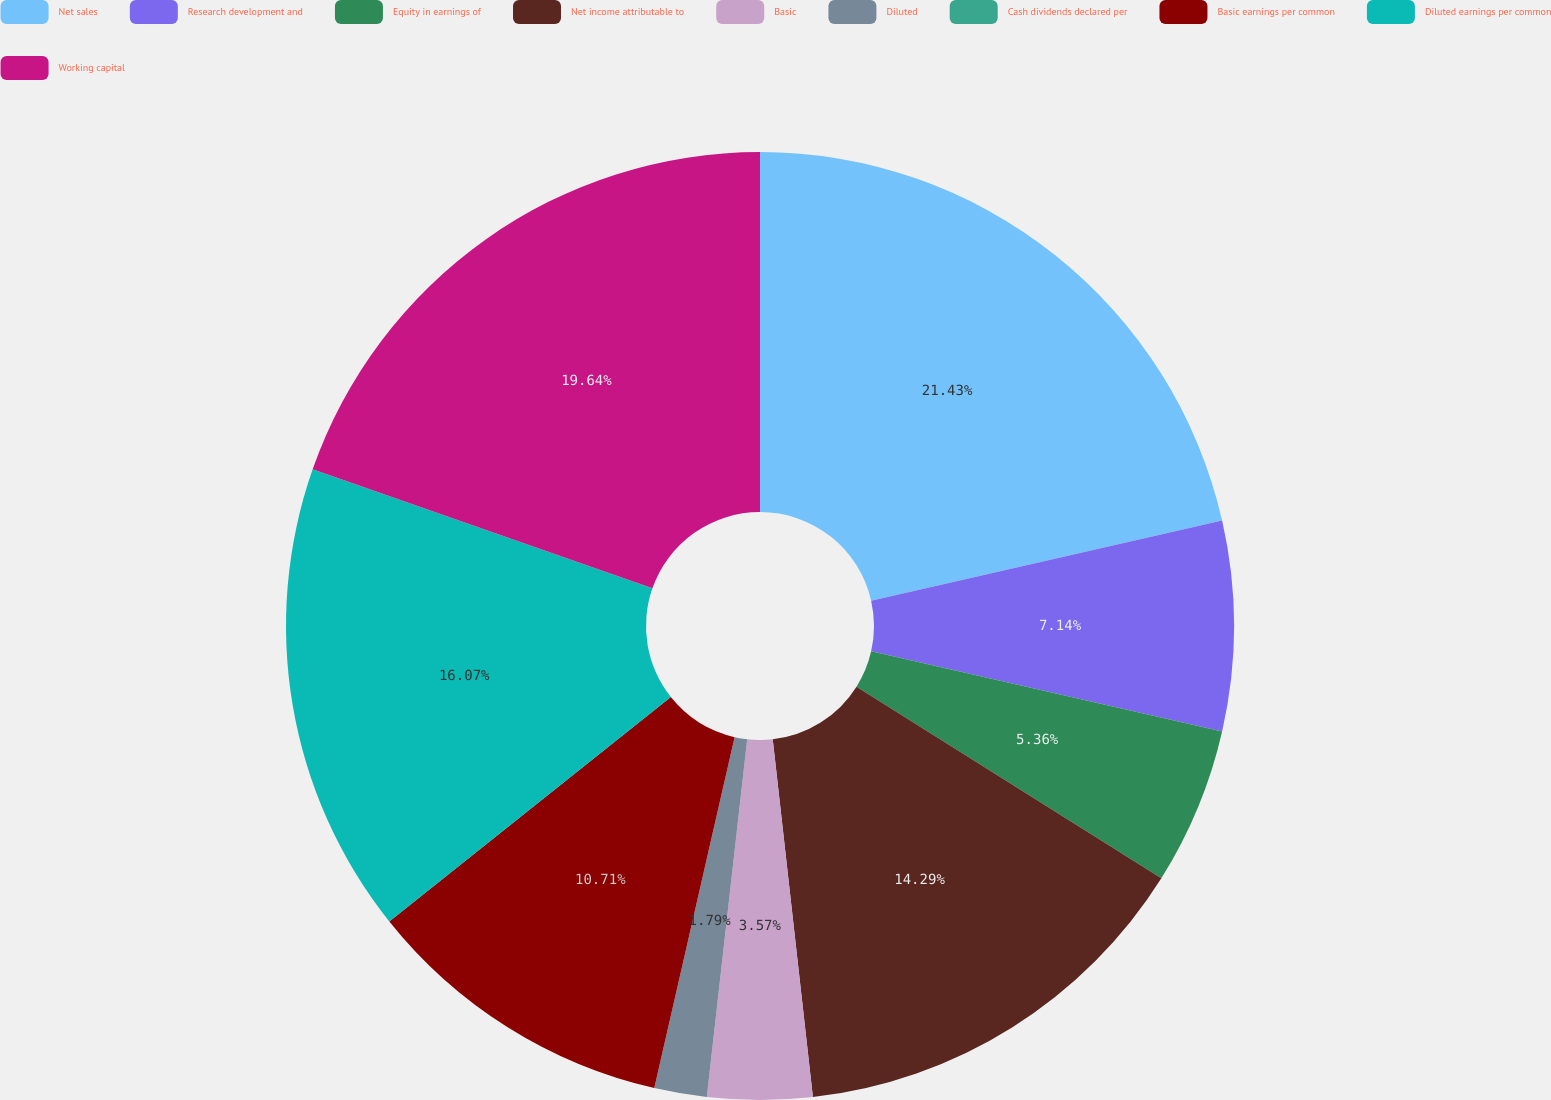Convert chart to OTSL. <chart><loc_0><loc_0><loc_500><loc_500><pie_chart><fcel>Net sales<fcel>Research development and<fcel>Equity in earnings of<fcel>Net income attributable to<fcel>Basic<fcel>Diluted<fcel>Cash dividends declared per<fcel>Basic earnings per common<fcel>Diluted earnings per common<fcel>Working capital<nl><fcel>21.43%<fcel>7.14%<fcel>5.36%<fcel>14.29%<fcel>3.57%<fcel>1.79%<fcel>0.0%<fcel>10.71%<fcel>16.07%<fcel>19.64%<nl></chart> 